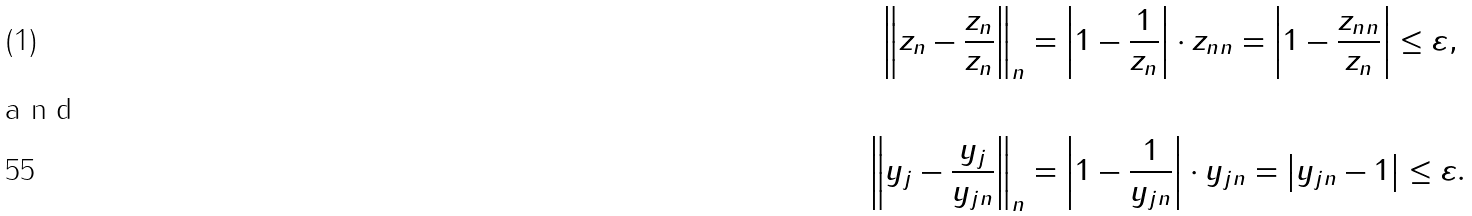<formula> <loc_0><loc_0><loc_500><loc_500>\left \| z _ { n } - \frac { z _ { n } } { \| z _ { n } \| } \right \| _ { n } & = \left | 1 - \frac { 1 } { \| z _ { n } \| } \right | \cdot \| z _ { n } \| _ { n } = \left | 1 - \frac { \| z _ { n } \| _ { n } } { \| z _ { n } \| } \right | \leq \varepsilon , \intertext { a n d } \left \| y _ { j } - \frac { y _ { j } } { \| y _ { j } \| _ { n } } \right \| _ { n } & = \left | 1 - \frac { 1 } { \| y _ { j } \| _ { n } } \right | \cdot \| y _ { j } \| _ { n } = \left | { \| y _ { j } \| _ { n } } - 1 \right | \leq \varepsilon .</formula> 